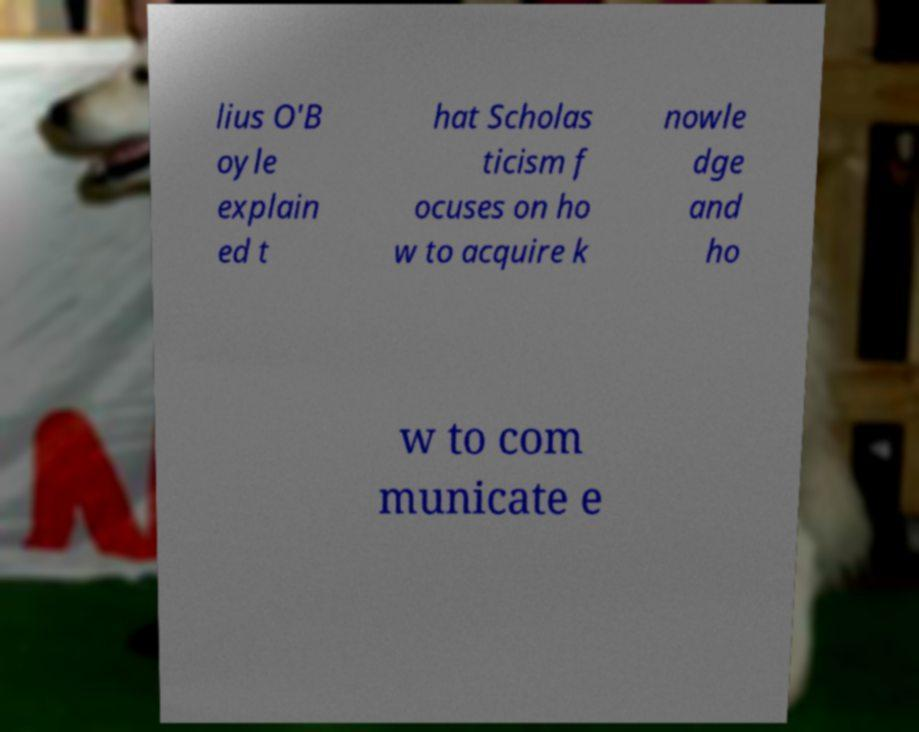Can you read and provide the text displayed in the image?This photo seems to have some interesting text. Can you extract and type it out for me? lius O'B oyle explain ed t hat Scholas ticism f ocuses on ho w to acquire k nowle dge and ho w to com municate e 